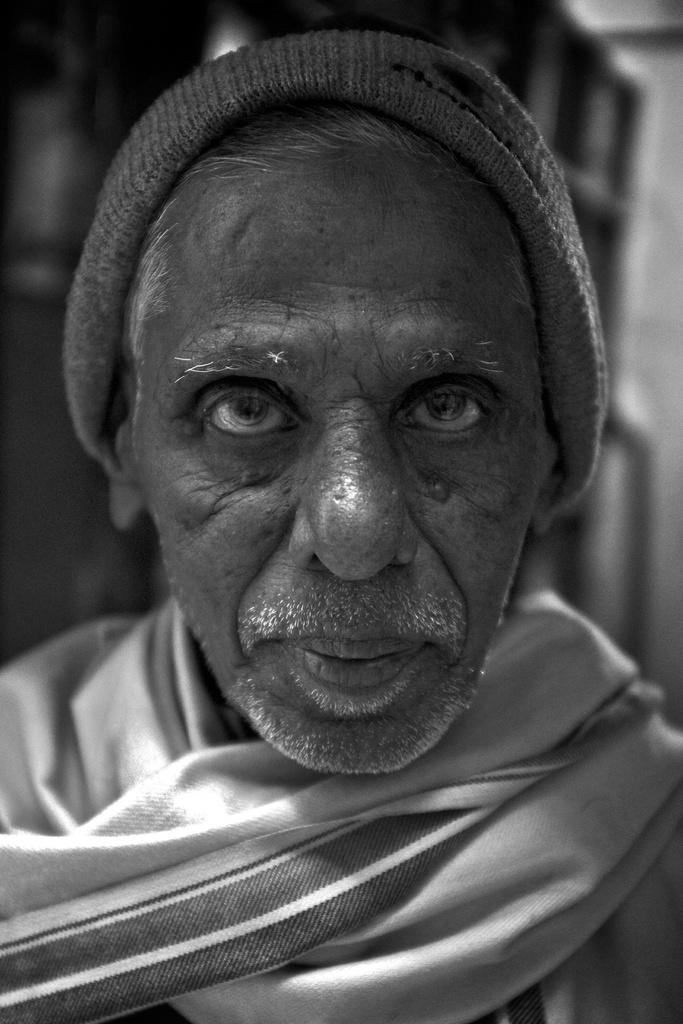What is the color scheme of the image? The image is black and white. Can you describe the person in the image? The person is wearing a scarf and a monkey cap. What can be seen in the background of the image? There is a building in the background of the image. How many pigs are present in the image? There are no pigs present in the image. What type of boundary can be seen surrounding the person in the image? There is no boundary surrounding the person in the image. 